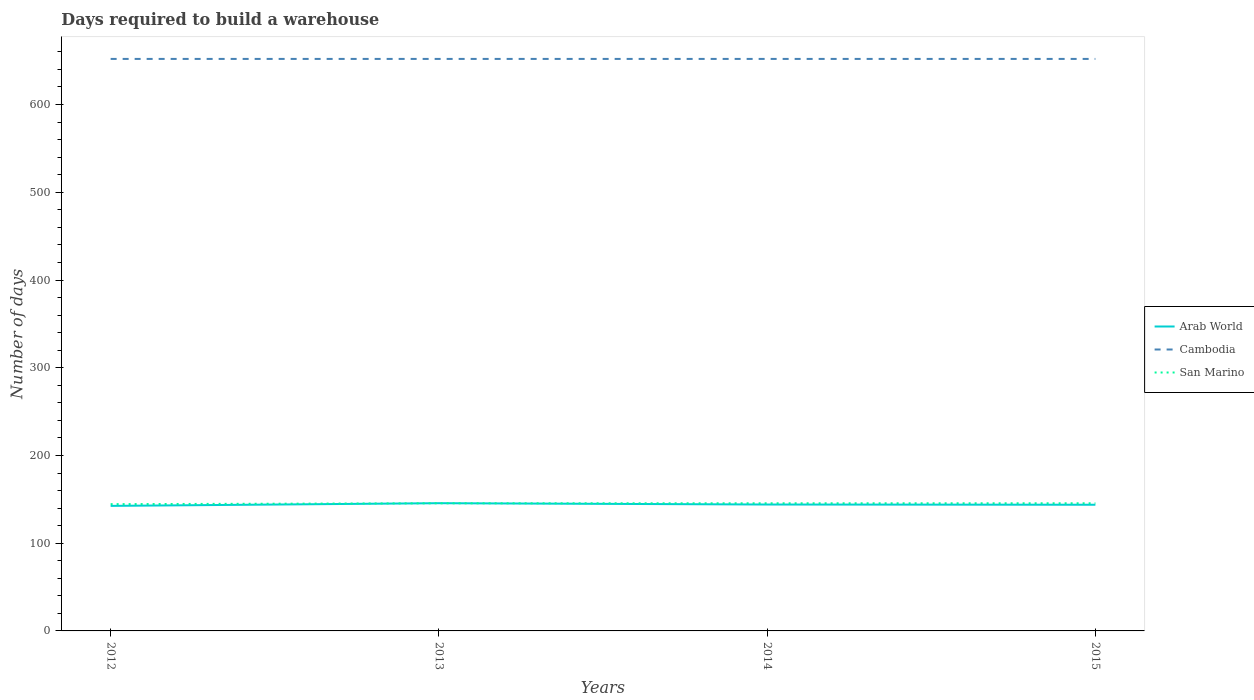Does the line corresponding to Cambodia intersect with the line corresponding to Arab World?
Make the answer very short. No. Is the number of lines equal to the number of legend labels?
Provide a short and direct response. Yes. Across all years, what is the maximum days required to build a warehouse in in Cambodia?
Make the answer very short. 652. What is the total days required to build a warehouse in in San Marino in the graph?
Provide a short and direct response. -1. What is the difference between the highest and the second highest days required to build a warehouse in in San Marino?
Give a very brief answer. 1. What is the difference between the highest and the lowest days required to build a warehouse in in Cambodia?
Provide a short and direct response. 0. How many lines are there?
Make the answer very short. 3. Does the graph contain grids?
Keep it short and to the point. No. Where does the legend appear in the graph?
Your answer should be very brief. Center right. What is the title of the graph?
Make the answer very short. Days required to build a warehouse. Does "Timor-Leste" appear as one of the legend labels in the graph?
Your answer should be very brief. No. What is the label or title of the Y-axis?
Your response must be concise. Number of days. What is the Number of days in Arab World in 2012?
Offer a very short reply. 142.53. What is the Number of days of Cambodia in 2012?
Your answer should be compact. 652. What is the Number of days in San Marino in 2012?
Ensure brevity in your answer.  144.5. What is the Number of days in Arab World in 2013?
Your answer should be compact. 145.61. What is the Number of days in Cambodia in 2013?
Your response must be concise. 652. What is the Number of days in San Marino in 2013?
Provide a short and direct response. 145.5. What is the Number of days of Arab World in 2014?
Keep it short and to the point. 144.08. What is the Number of days of Cambodia in 2014?
Give a very brief answer. 652. What is the Number of days of San Marino in 2014?
Ensure brevity in your answer.  145.5. What is the Number of days of Arab World in 2015?
Keep it short and to the point. 143.82. What is the Number of days in Cambodia in 2015?
Keep it short and to the point. 652. What is the Number of days in San Marino in 2015?
Your response must be concise. 145.5. Across all years, what is the maximum Number of days of Arab World?
Your answer should be very brief. 145.61. Across all years, what is the maximum Number of days of Cambodia?
Your answer should be compact. 652. Across all years, what is the maximum Number of days of San Marino?
Provide a succinct answer. 145.5. Across all years, what is the minimum Number of days in Arab World?
Your answer should be compact. 142.53. Across all years, what is the minimum Number of days of Cambodia?
Your response must be concise. 652. Across all years, what is the minimum Number of days of San Marino?
Your answer should be very brief. 144.5. What is the total Number of days of Arab World in the graph?
Your answer should be very brief. 576.02. What is the total Number of days of Cambodia in the graph?
Ensure brevity in your answer.  2608. What is the total Number of days in San Marino in the graph?
Give a very brief answer. 581. What is the difference between the Number of days in Arab World in 2012 and that in 2013?
Give a very brief answer. -3.08. What is the difference between the Number of days in Cambodia in 2012 and that in 2013?
Your answer should be very brief. 0. What is the difference between the Number of days in San Marino in 2012 and that in 2013?
Give a very brief answer. -1. What is the difference between the Number of days in Arab World in 2012 and that in 2014?
Offer a very short reply. -1.55. What is the difference between the Number of days in San Marino in 2012 and that in 2014?
Provide a succinct answer. -1. What is the difference between the Number of days of Arab World in 2012 and that in 2015?
Offer a very short reply. -1.29. What is the difference between the Number of days of Cambodia in 2012 and that in 2015?
Offer a very short reply. 0. What is the difference between the Number of days in San Marino in 2012 and that in 2015?
Provide a short and direct response. -1. What is the difference between the Number of days of Arab World in 2013 and that in 2014?
Your response must be concise. 1.53. What is the difference between the Number of days of Cambodia in 2013 and that in 2014?
Give a very brief answer. 0. What is the difference between the Number of days in San Marino in 2013 and that in 2014?
Keep it short and to the point. 0. What is the difference between the Number of days of Arab World in 2013 and that in 2015?
Offer a very short reply. 1.79. What is the difference between the Number of days of Cambodia in 2013 and that in 2015?
Provide a short and direct response. 0. What is the difference between the Number of days in Arab World in 2014 and that in 2015?
Your response must be concise. 0.26. What is the difference between the Number of days of San Marino in 2014 and that in 2015?
Keep it short and to the point. 0. What is the difference between the Number of days in Arab World in 2012 and the Number of days in Cambodia in 2013?
Ensure brevity in your answer.  -509.48. What is the difference between the Number of days of Arab World in 2012 and the Number of days of San Marino in 2013?
Ensure brevity in your answer.  -2.98. What is the difference between the Number of days in Cambodia in 2012 and the Number of days in San Marino in 2013?
Your answer should be very brief. 506.5. What is the difference between the Number of days of Arab World in 2012 and the Number of days of Cambodia in 2014?
Give a very brief answer. -509.48. What is the difference between the Number of days in Arab World in 2012 and the Number of days in San Marino in 2014?
Your answer should be very brief. -2.98. What is the difference between the Number of days of Cambodia in 2012 and the Number of days of San Marino in 2014?
Offer a very short reply. 506.5. What is the difference between the Number of days in Arab World in 2012 and the Number of days in Cambodia in 2015?
Ensure brevity in your answer.  -509.48. What is the difference between the Number of days in Arab World in 2012 and the Number of days in San Marino in 2015?
Keep it short and to the point. -2.98. What is the difference between the Number of days of Cambodia in 2012 and the Number of days of San Marino in 2015?
Make the answer very short. 506.5. What is the difference between the Number of days in Arab World in 2013 and the Number of days in Cambodia in 2014?
Ensure brevity in your answer.  -506.39. What is the difference between the Number of days in Arab World in 2013 and the Number of days in San Marino in 2014?
Your response must be concise. 0.11. What is the difference between the Number of days of Cambodia in 2013 and the Number of days of San Marino in 2014?
Your answer should be compact. 506.5. What is the difference between the Number of days of Arab World in 2013 and the Number of days of Cambodia in 2015?
Keep it short and to the point. -506.39. What is the difference between the Number of days in Arab World in 2013 and the Number of days in San Marino in 2015?
Offer a terse response. 0.11. What is the difference between the Number of days of Cambodia in 2013 and the Number of days of San Marino in 2015?
Your response must be concise. 506.5. What is the difference between the Number of days in Arab World in 2014 and the Number of days in Cambodia in 2015?
Ensure brevity in your answer.  -507.92. What is the difference between the Number of days in Arab World in 2014 and the Number of days in San Marino in 2015?
Provide a short and direct response. -1.42. What is the difference between the Number of days of Cambodia in 2014 and the Number of days of San Marino in 2015?
Offer a very short reply. 506.5. What is the average Number of days in Arab World per year?
Give a very brief answer. 144.01. What is the average Number of days of Cambodia per year?
Provide a succinct answer. 652. What is the average Number of days of San Marino per year?
Your answer should be very brief. 145.25. In the year 2012, what is the difference between the Number of days of Arab World and Number of days of Cambodia?
Your answer should be very brief. -509.48. In the year 2012, what is the difference between the Number of days in Arab World and Number of days in San Marino?
Offer a very short reply. -1.98. In the year 2012, what is the difference between the Number of days of Cambodia and Number of days of San Marino?
Your answer should be very brief. 507.5. In the year 2013, what is the difference between the Number of days in Arab World and Number of days in Cambodia?
Your answer should be very brief. -506.39. In the year 2013, what is the difference between the Number of days of Arab World and Number of days of San Marino?
Ensure brevity in your answer.  0.11. In the year 2013, what is the difference between the Number of days in Cambodia and Number of days in San Marino?
Provide a short and direct response. 506.5. In the year 2014, what is the difference between the Number of days of Arab World and Number of days of Cambodia?
Offer a terse response. -507.92. In the year 2014, what is the difference between the Number of days in Arab World and Number of days in San Marino?
Offer a terse response. -1.42. In the year 2014, what is the difference between the Number of days of Cambodia and Number of days of San Marino?
Your answer should be very brief. 506.5. In the year 2015, what is the difference between the Number of days of Arab World and Number of days of Cambodia?
Give a very brief answer. -508.18. In the year 2015, what is the difference between the Number of days of Arab World and Number of days of San Marino?
Make the answer very short. -1.68. In the year 2015, what is the difference between the Number of days of Cambodia and Number of days of San Marino?
Make the answer very short. 506.5. What is the ratio of the Number of days in Arab World in 2012 to that in 2013?
Make the answer very short. 0.98. What is the ratio of the Number of days in Cambodia in 2012 to that in 2013?
Offer a terse response. 1. What is the ratio of the Number of days of Arab World in 2012 to that in 2014?
Offer a terse response. 0.99. What is the ratio of the Number of days in Cambodia in 2012 to that in 2014?
Offer a very short reply. 1. What is the ratio of the Number of days of Cambodia in 2012 to that in 2015?
Provide a succinct answer. 1. What is the ratio of the Number of days of San Marino in 2012 to that in 2015?
Keep it short and to the point. 0.99. What is the ratio of the Number of days of Arab World in 2013 to that in 2014?
Make the answer very short. 1.01. What is the ratio of the Number of days in Cambodia in 2013 to that in 2014?
Make the answer very short. 1. What is the ratio of the Number of days in Arab World in 2013 to that in 2015?
Give a very brief answer. 1.01. What is the ratio of the Number of days of Cambodia in 2013 to that in 2015?
Ensure brevity in your answer.  1. What is the ratio of the Number of days of San Marino in 2013 to that in 2015?
Offer a very short reply. 1. What is the ratio of the Number of days of Arab World in 2014 to that in 2015?
Make the answer very short. 1. What is the ratio of the Number of days of Cambodia in 2014 to that in 2015?
Make the answer very short. 1. What is the ratio of the Number of days of San Marino in 2014 to that in 2015?
Your answer should be very brief. 1. What is the difference between the highest and the second highest Number of days of Arab World?
Keep it short and to the point. 1.53. What is the difference between the highest and the second highest Number of days in Cambodia?
Keep it short and to the point. 0. What is the difference between the highest and the second highest Number of days in San Marino?
Give a very brief answer. 0. What is the difference between the highest and the lowest Number of days of Arab World?
Your response must be concise. 3.08. What is the difference between the highest and the lowest Number of days in Cambodia?
Your answer should be very brief. 0. What is the difference between the highest and the lowest Number of days in San Marino?
Your answer should be very brief. 1. 